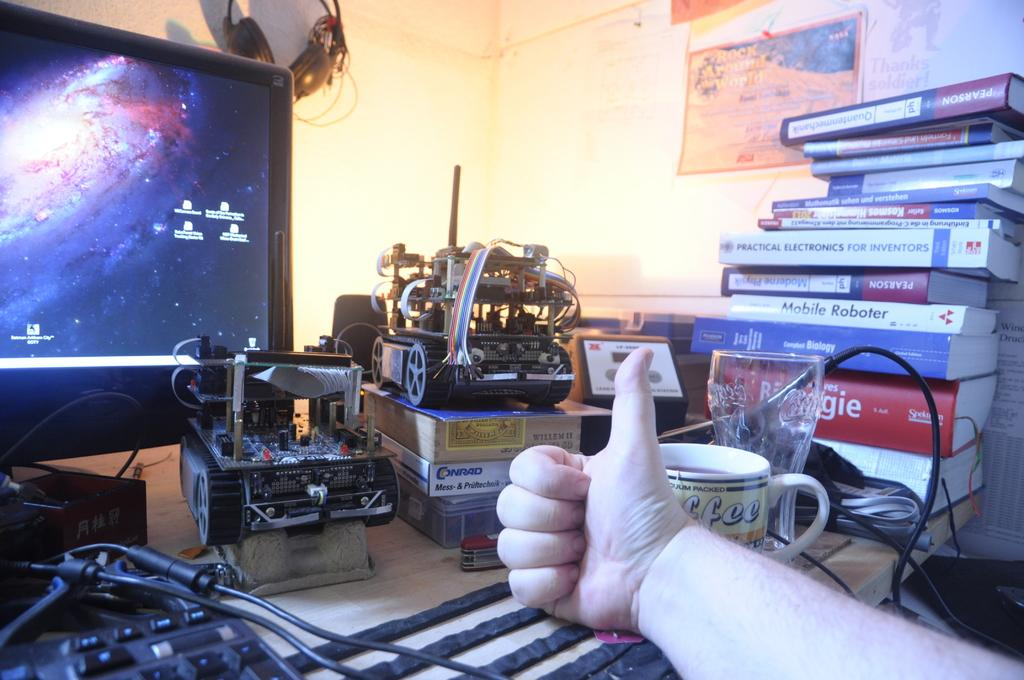<image>
Present a compact description of the photo's key features. thumbs up in front of robotic parts and books including mobile roboter, computer biology, and practical electronics for inventors 